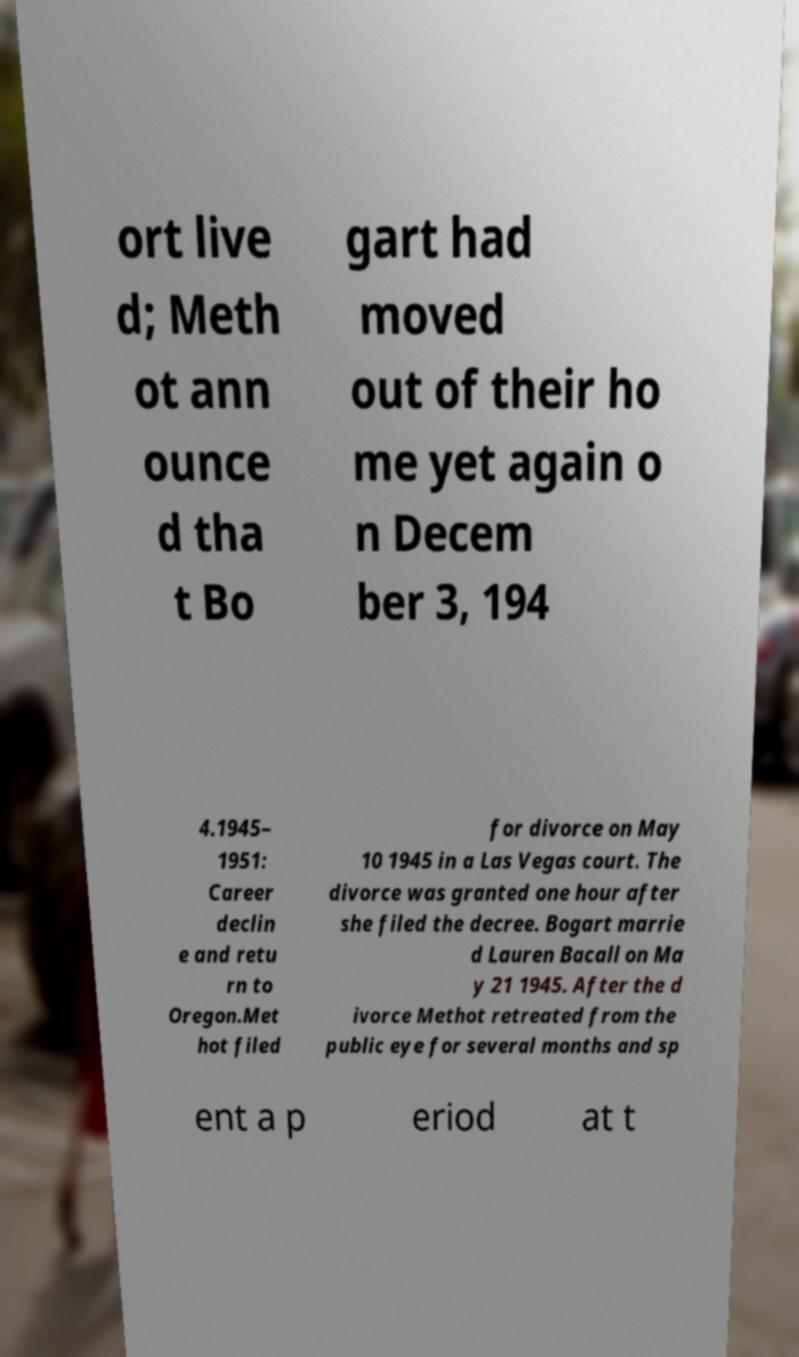There's text embedded in this image that I need extracted. Can you transcribe it verbatim? ort live d; Meth ot ann ounce d tha t Bo gart had moved out of their ho me yet again o n Decem ber 3, 194 4.1945– 1951: Career declin e and retu rn to Oregon.Met hot filed for divorce on May 10 1945 in a Las Vegas court. The divorce was granted one hour after she filed the decree. Bogart marrie d Lauren Bacall on Ma y 21 1945. After the d ivorce Methot retreated from the public eye for several months and sp ent a p eriod at t 